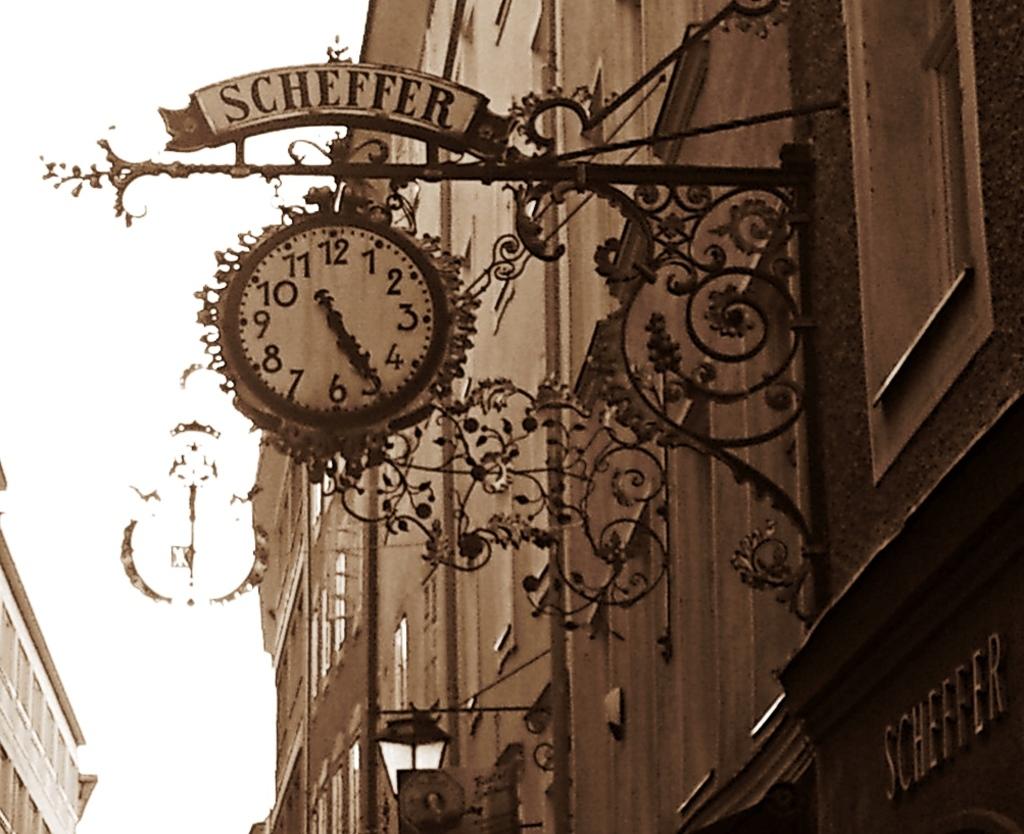What does the sign say above the clock?
Provide a succinct answer. Scheffer. 